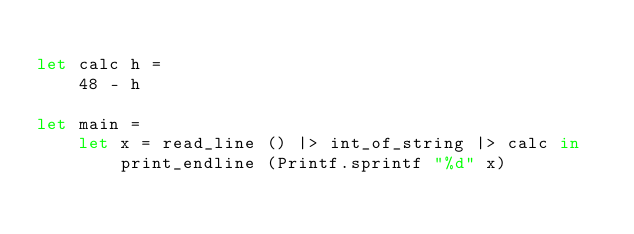Convert code to text. <code><loc_0><loc_0><loc_500><loc_500><_OCaml_>
let calc h =
    48 - h

let main =
    let x = read_line () |> int_of_string |> calc in
        print_endline (Printf.sprintf "%d" x)

</code> 